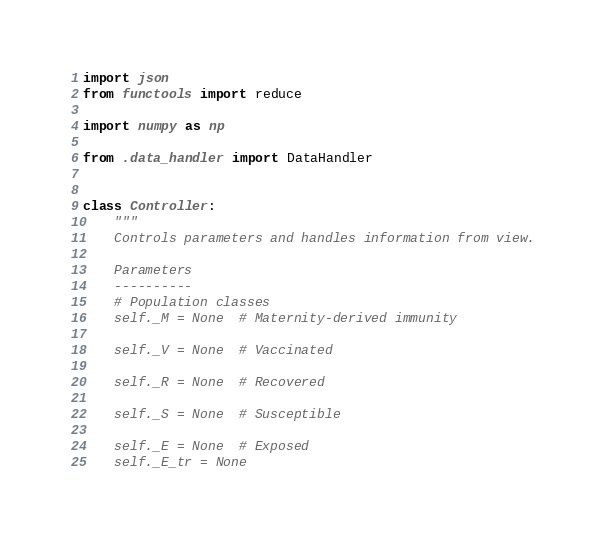<code> <loc_0><loc_0><loc_500><loc_500><_Python_>import json
from functools import reduce

import numpy as np

from .data_handler import DataHandler


class Controller:
    """
    Controls parameters and handles information from view.

    Parameters
    ----------
    # Population classes
    self._M = None  # Maternity-derived immunity

    self._V = None  # Vaccinated

    self._R = None  # Recovered

    self._S = None  # Susceptible

    self._E = None  # Exposed
    self._E_tr = None</code> 